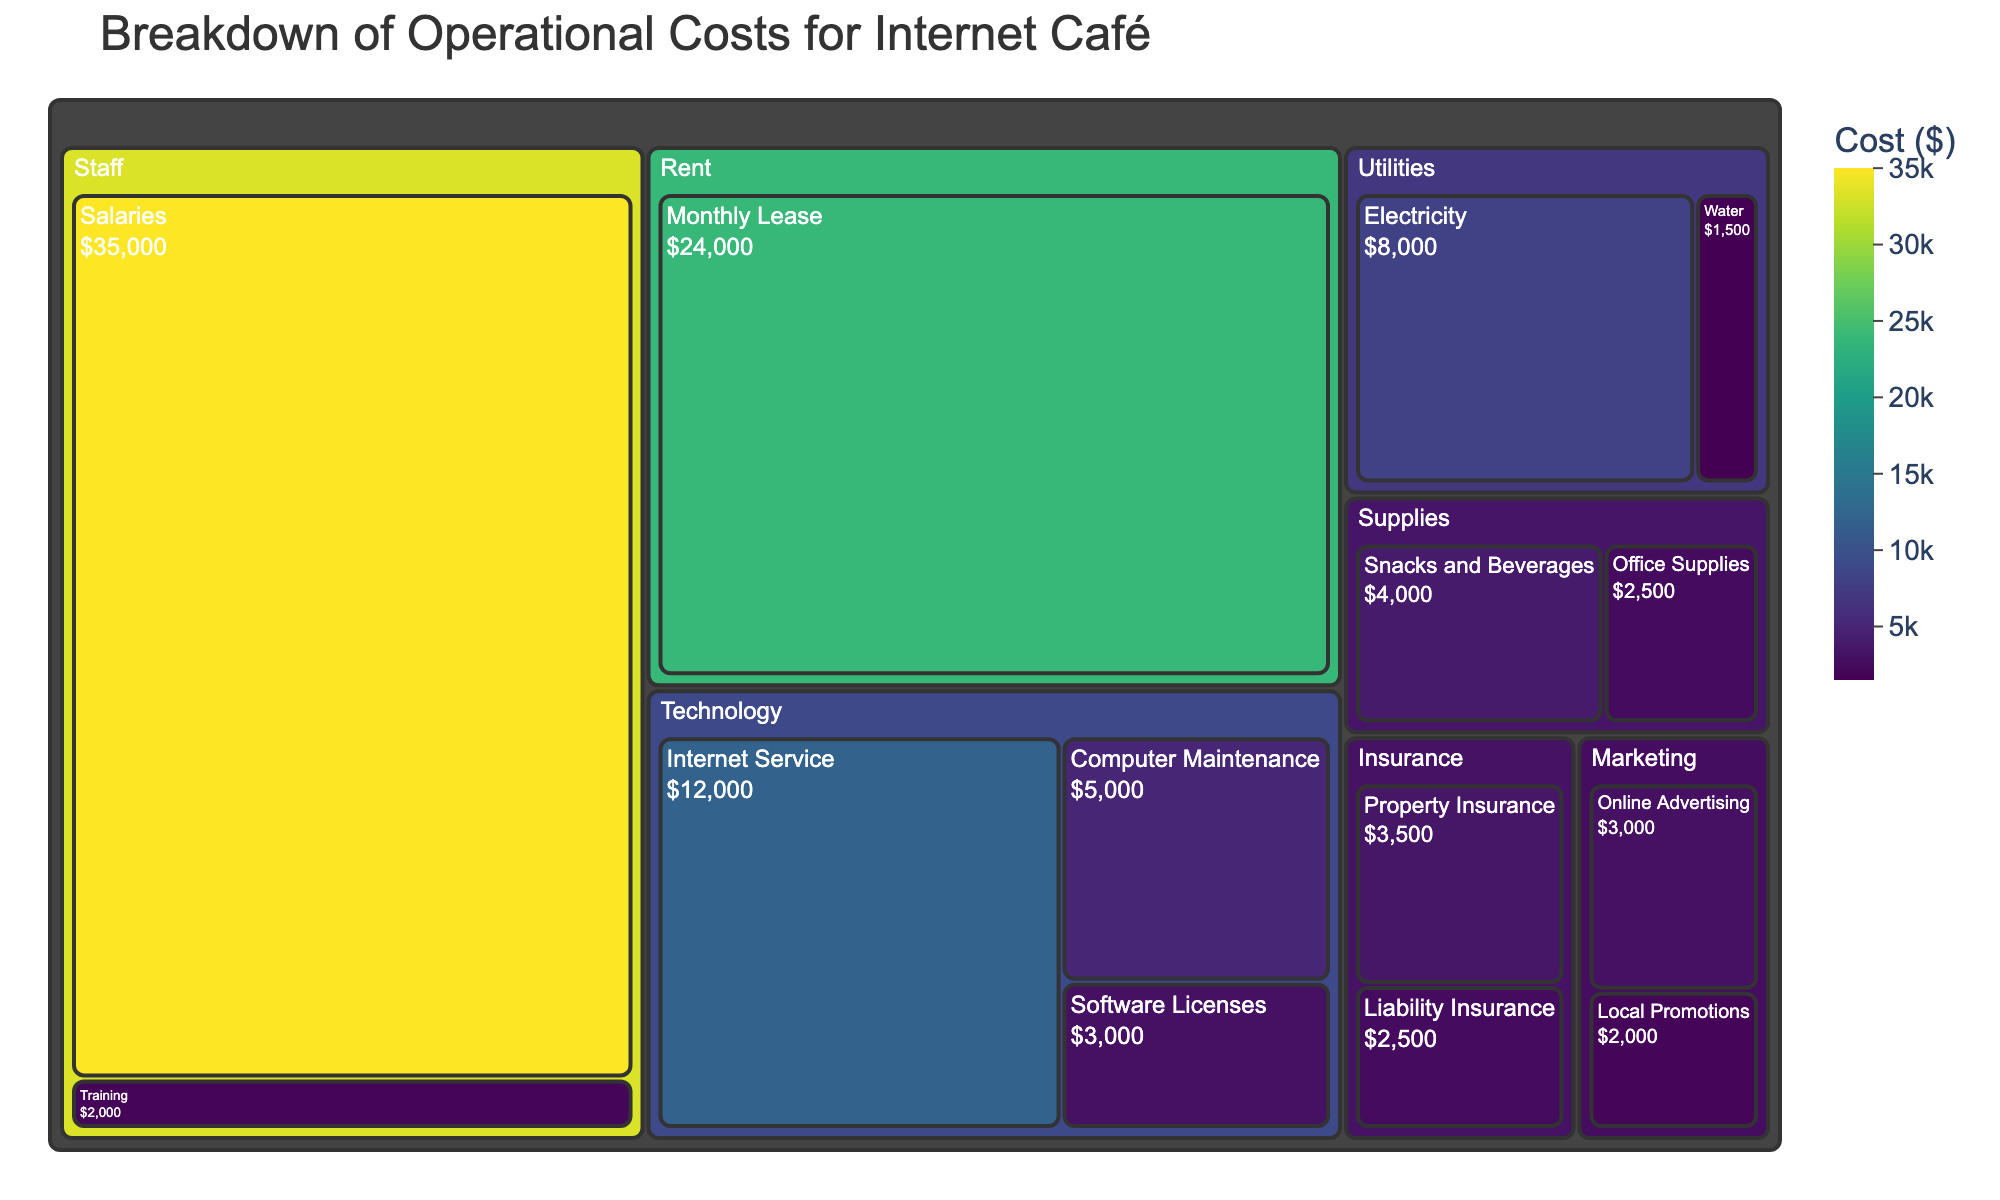How much do Salaries cost? Locate the "Staff" category, then find the "Salaries" subcategory. The figure indicates that the cost for Salaries is $35,000.
Answer: $35,000 What is the total operational cost for Technology? Add the costs of "Internet Service", "Computer Maintenance", and "Software Licenses" within the Technology category. The costs are $12,000, $5,000, and $3,000 respectively. So, the total cost is $12,000 + $5,000 + $3,000 = $20,000.
Answer: $20,000 Which category has the highest operational cost? Compare the total costs of each category by examining their respective areas in the Treemap. The "Staff" category has the largest area, indicating it has the highest operational cost, totaling $37,000 for Salaries and Training.
Answer: Staff How does the cost of Electricity compare to the cost of Internet Service? Compare the values of the "Electricity" subcategory under "Utilities" ($8,000) and "Internet Service" under "Technology" ($12,000). The cost of Internet Service is higher.
Answer: Internet Service is higher What percentage of the total operational cost does the Monthly Lease represent? Calculate the percentage by dividing the Monthly Lease cost by the total operational costs, then multiply by 100. Monthly Lease is $24,000. The total cost is $102,500 (summing all subcategories). So, the percentage is ($24,000 / $102,500) * 100 ≈ 23.41%.
Answer: ≈ 23.41% Which subcategory under Supplies has a higher cost, Office Supplies or Snacks and Beverages? Compare the values of the "Office Supplies" subcategory ($2,500) and "Snacks and Beverages" subcategory ($4,000). The cost of Snacks and Beverages is higher.
Answer: Snacks and Beverages How much do Marketing costs contribute to the total operational cost? Add the "Online Advertising" and "Local Promotions" costs under Marketing. The costs are $3,000 and $2,000 respectively. The total cost is $3,000 + $2,000 = $5,000.
Answer: $5,000 What's the most costly subcategory in Insurance? Compare the values of the two subcategories under Insurance: "Property Insurance" ($3,500) and "Liability Insurance" ($2,500). "Property Insurance" has the higher cost.
Answer: Property Insurance What is the combined cost of Utilities? Add the values of "Electricity" and "Water" under Utilities. The costs are $8,000 (Electricity) and $1,500 (Water). So, the total is $8,000 + $1,500 = $9,500.
Answer: $9,500 Compare the operational costs of Training and Local Promotions. Which one is higher? Compare the values of "Training" ($2,000) under Staff and "Local Promotions" ($2,000) under Marketing. Both have the same cost.
Answer: They are equal 